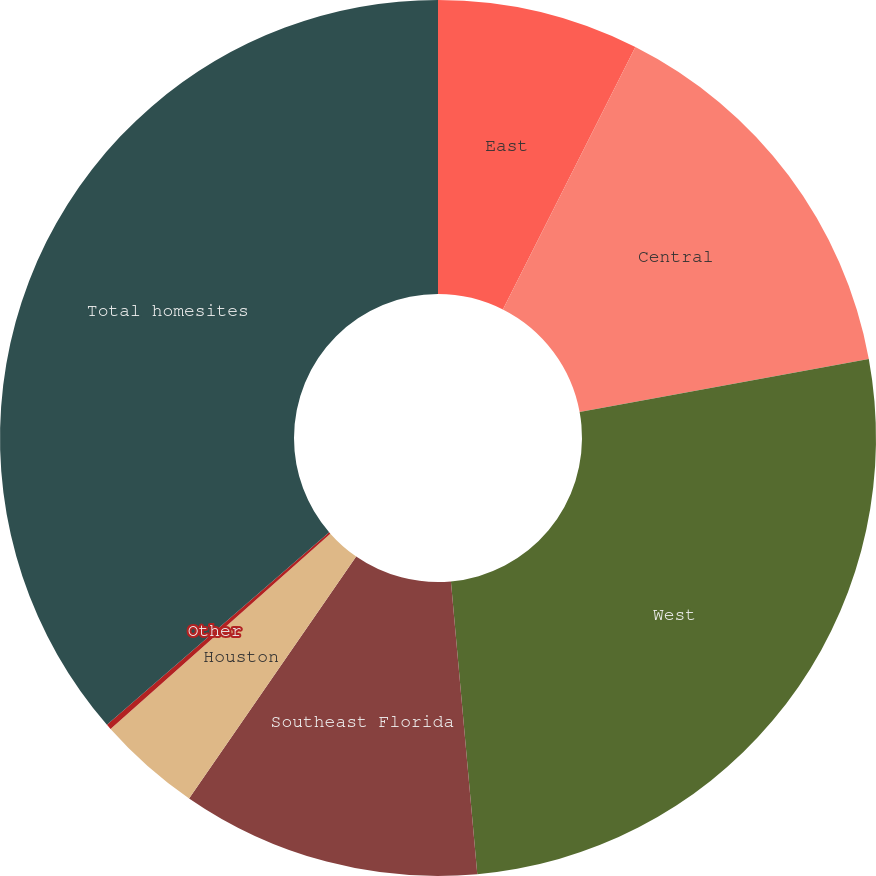Convert chart. <chart><loc_0><loc_0><loc_500><loc_500><pie_chart><fcel>East<fcel>Central<fcel>West<fcel>Southeast Florida<fcel>Houston<fcel>Other<fcel>Total homesites<nl><fcel>7.44%<fcel>14.67%<fcel>26.46%<fcel>11.05%<fcel>3.82%<fcel>0.2%<fcel>36.36%<nl></chart> 